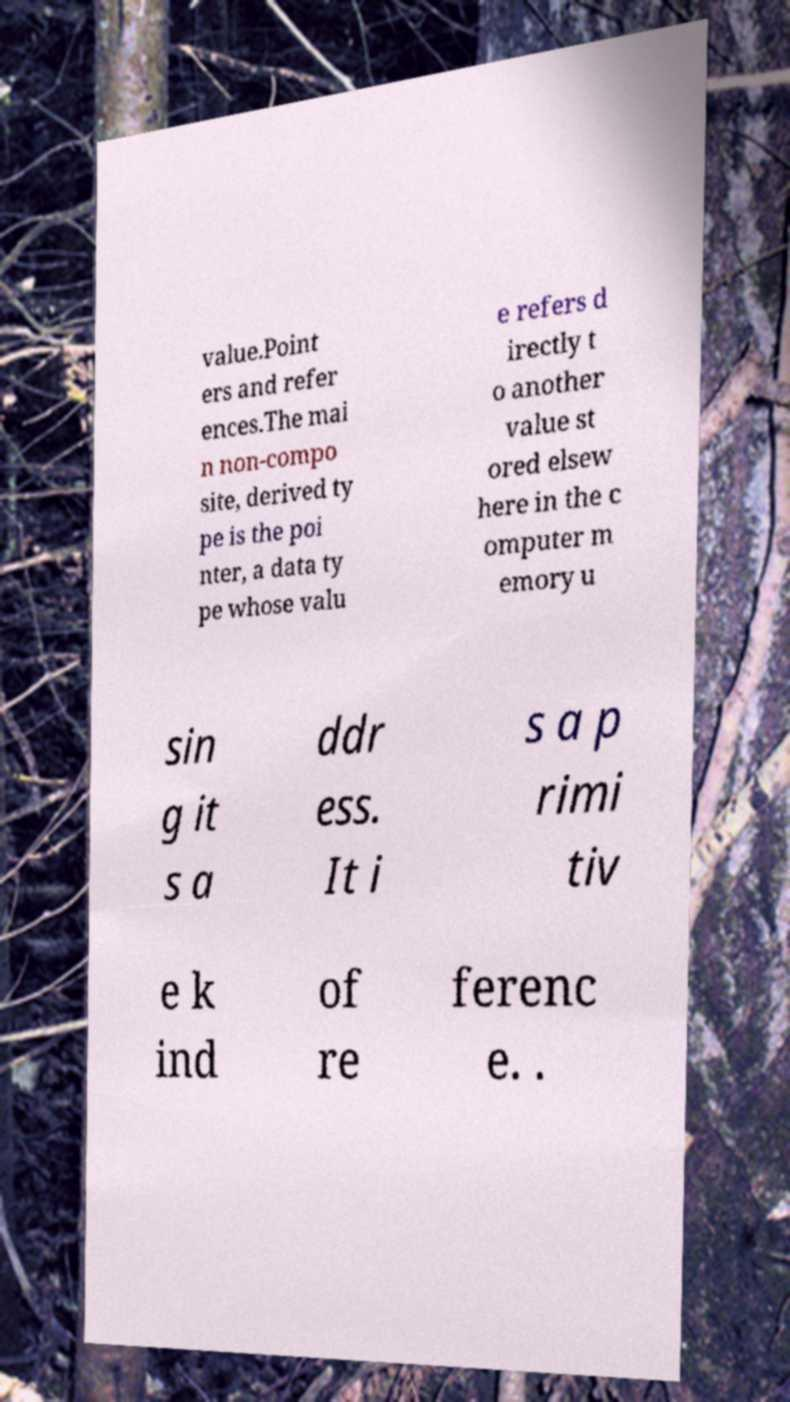Please read and relay the text visible in this image. What does it say? value.Point ers and refer ences.The mai n non-compo site, derived ty pe is the poi nter, a data ty pe whose valu e refers d irectly t o another value st ored elsew here in the c omputer m emory u sin g it s a ddr ess. It i s a p rimi tiv e k ind of re ferenc e. . 